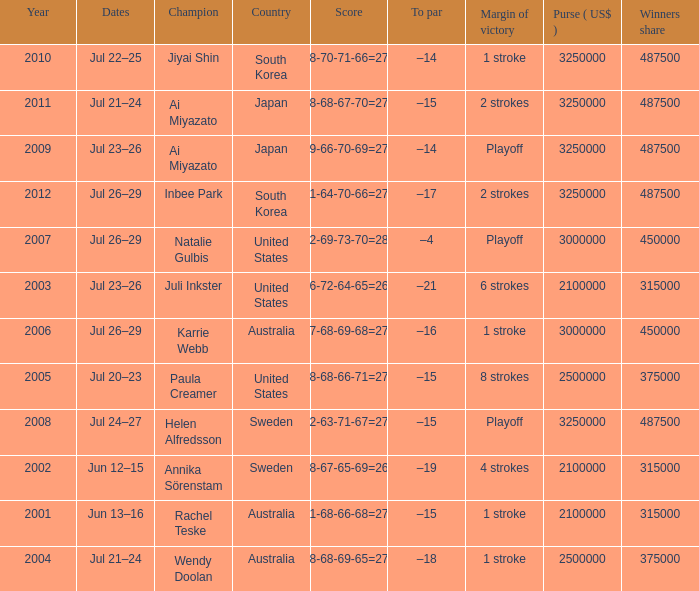How many years was Jiyai Shin the champion? 1.0. 